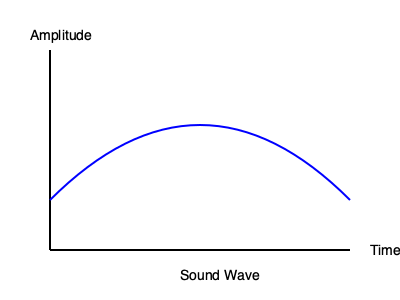Analyze the sound wave depicted in the graph. If this wave represents a musical note with a frequency of 440 Hz (A4), what would be the frequency of the same note played one octave higher, and how would the wave's appearance change? To answer this question, we need to understand the relationship between octaves and frequency, as well as how frequency affects the appearance of sound waves.

1. Frequency and octaves:
   - The frequency of a note doubles when raised by one octave.
   - Given frequency: 440 Hz (A4)
   - One octave higher: $440 \times 2 = 880$ Hz (A5)

2. Wave appearance:
   - Frequency is inversely proportional to wavelength: $f = \frac{v}{\lambda}$
   - Where $f$ is frequency, $v$ is speed of sound, and $\lambda$ is wavelength
   - Doubling the frequency halves the wavelength

3. Changes in the wave graph:
   - The wave will complete twice as many cycles in the same time period
   - The distance between peaks (wavelength) will be reduced by half
   - The amplitude (height of the wave) remains unchanged, as it represents volume, not pitch

4. Mathematical representation:
   - Original wave: $y = A \sin(2\pi f t)$
   - New wave: $y = A \sin(2\pi (2f) t)$
   - Where $A$ is amplitude, $f$ is frequency, and $t$ is time

In summary, the frequency would be 880 Hz, and the wave would appear more compressed horizontally, with twice as many peaks and troughs in the same time interval.
Answer: 880 Hz; wave appears more compressed horizontally 